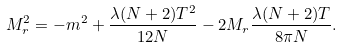<formula> <loc_0><loc_0><loc_500><loc_500>M _ { r } ^ { 2 } = - m ^ { 2 } + \frac { \lambda ( N + 2 ) T ^ { 2 } } { 1 2 N } - 2 M _ { r } \frac { \lambda ( N + 2 ) T } { 8 \pi N } .</formula> 